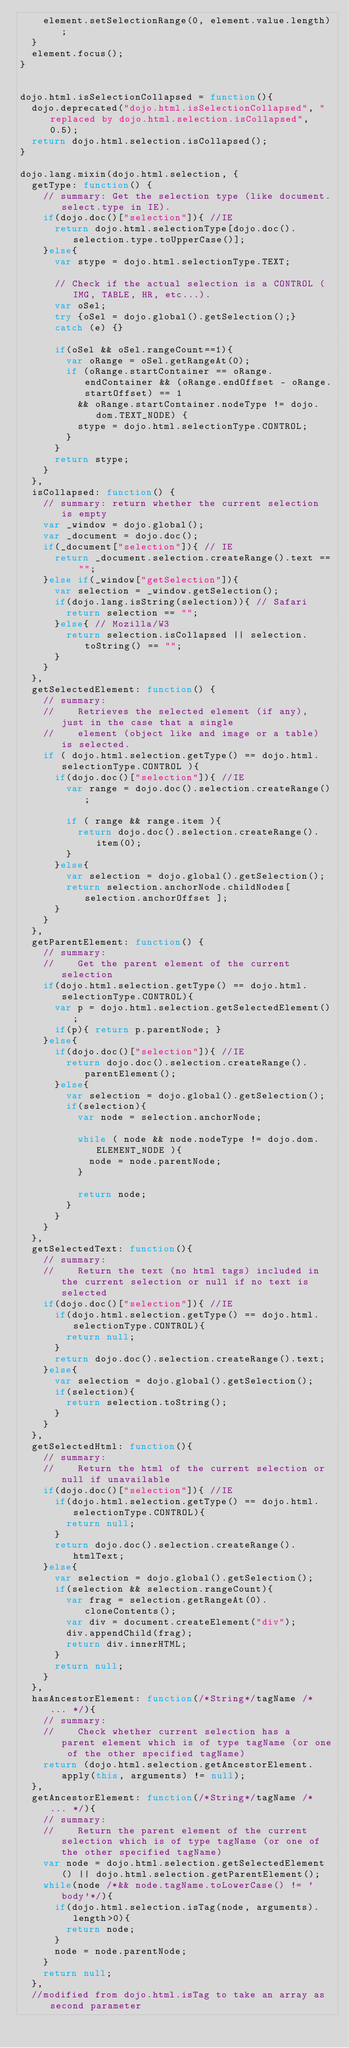Convert code to text. <code><loc_0><loc_0><loc_500><loc_500><_JavaScript_>		element.setSelectionRange(0, element.value.length);
	}
	element.focus();
}


dojo.html.isSelectionCollapsed = function(){
	dojo.deprecated("dojo.html.isSelectionCollapsed", "replaced by dojo.html.selection.isCollapsed", 0.5);
	return dojo.html.selection.isCollapsed();
}

dojo.lang.mixin(dojo.html.selection, {
	getType: function() {
		// summary: Get the selection type (like document.select.type in IE).
		if(dojo.doc()["selection"]){ //IE
			return dojo.html.selectionType[dojo.doc().selection.type.toUpperCase()];
		}else{
			var stype = dojo.html.selectionType.TEXT;

			// Check if the actual selection is a CONTROL (IMG, TABLE, HR, etc...).
			var oSel;
			try {oSel = dojo.global().getSelection();}
			catch (e) {}

			if(oSel && oSel.rangeCount==1){
				var oRange = oSel.getRangeAt(0);
				if (oRange.startContainer == oRange.endContainer && (oRange.endOffset - oRange.startOffset) == 1
					&& oRange.startContainer.nodeType != dojo.dom.TEXT_NODE) {
					stype = dojo.html.selectionType.CONTROL;
				}
			}
			return stype;
		}
	},
	isCollapsed: function() {
		// summary: return whether the current selection is empty
		var _window = dojo.global();
		var _document = dojo.doc();
		if(_document["selection"]){ // IE
			return _document.selection.createRange().text == "";
		}else if(_window["getSelection"]){
			var selection = _window.getSelection();
			if(dojo.lang.isString(selection)){ // Safari
				return selection == "";
			}else{ // Mozilla/W3
				return selection.isCollapsed || selection.toString() == "";
			}
		}
	},
	getSelectedElement: function() {
		// summary:
		//		Retrieves the selected element (if any), just in the case that a single
		//		element (object like and image or a table) is selected.
		if ( dojo.html.selection.getType() == dojo.html.selectionType.CONTROL ){
			if(dojo.doc()["selection"]){ //IE
				var range = dojo.doc().selection.createRange();

				if ( range && range.item ){
					return dojo.doc().selection.createRange().item(0);
				}
			}else{
				var selection = dojo.global().getSelection();
				return selection.anchorNode.childNodes[ selection.anchorOffset ];
			}
		}
	},
	getParentElement: function() {
		// summary:
		//		Get the parent element of the current selection
		if(dojo.html.selection.getType() == dojo.html.selectionType.CONTROL){
			var p = dojo.html.selection.getSelectedElement();
			if(p){ return p.parentNode; }
		}else{
			if(dojo.doc()["selection"]){ //IE
				return dojo.doc().selection.createRange().parentElement();
			}else{
				var selection = dojo.global().getSelection();
				if(selection){
					var node = selection.anchorNode;

					while ( node && node.nodeType != dojo.dom.ELEMENT_NODE ){
						node = node.parentNode;
					}

					return node;
				}
			}
		}
	},
	getSelectedText: function(){
		// summary:
		//		Return the text (no html tags) included in the current selection or null if no text is selected
		if(dojo.doc()["selection"]){ //IE
			if(dojo.html.selection.getType() == dojo.html.selectionType.CONTROL){
				return null;
			}
			return dojo.doc().selection.createRange().text;
		}else{
			var selection = dojo.global().getSelection();
			if(selection){
				return selection.toString();
			}
		}
	},
	getSelectedHtml: function(){
		// summary:
		//		Return the html of the current selection or null if unavailable
		if(dojo.doc()["selection"]){ //IE
			if(dojo.html.selection.getType() == dojo.html.selectionType.CONTROL){
				return null;
			}
			return dojo.doc().selection.createRange().htmlText;
		}else{
			var selection = dojo.global().getSelection();
			if(selection && selection.rangeCount){
				var frag = selection.getRangeAt(0).cloneContents();
				var div = document.createElement("div");
				div.appendChild(frag);
				return div.innerHTML;
			}
			return null;
		}
	},
	hasAncestorElement: function(/*String*/tagName /* ... */){
		// summary:
		// 		Check whether current selection has a  parent element which is of type tagName (or one of the other specified tagName)
		return (dojo.html.selection.getAncestorElement.apply(this, arguments) != null);
	},
	getAncestorElement: function(/*String*/tagName /* ... */){
		// summary:
		//		Return the parent element of the current selection which is of type tagName (or one of the other specified tagName)
		var node = dojo.html.selection.getSelectedElement() || dojo.html.selection.getParentElement();
		while(node /*&& node.tagName.toLowerCase() != 'body'*/){
			if(dojo.html.selection.isTag(node, arguments).length>0){
				return node;
			}
			node = node.parentNode;
		}
		return null;
	},
	//modified from dojo.html.isTag to take an array as second parameter</code> 